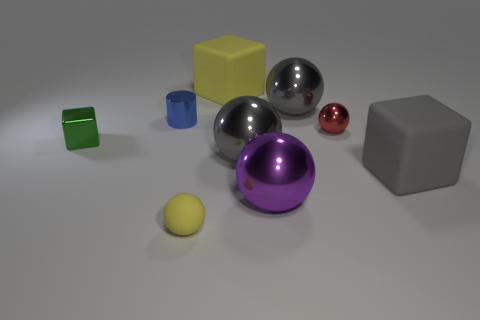Is there anything else that has the same shape as the tiny blue metal object?
Keep it short and to the point. No. Is there a gray thing of the same size as the purple metallic ball?
Give a very brief answer. Yes. Is the color of the matte cube that is in front of the small green shiny object the same as the metallic block?
Give a very brief answer. No. There is a rubber object that is left of the purple metallic object and in front of the tiny shiny block; what color is it?
Make the answer very short. Yellow. There is a blue metal object that is the same size as the yellow ball; what shape is it?
Give a very brief answer. Cylinder. Is there another tiny blue thing of the same shape as the blue metallic object?
Provide a short and direct response. No. There is a ball behind the cylinder; is it the same size as the large gray block?
Your response must be concise. Yes. There is a metallic object that is in front of the small blue object and left of the yellow cube; how big is it?
Offer a terse response. Small. What number of other things are the same material as the blue object?
Your response must be concise. 5. What size is the yellow rubber thing behind the tiny rubber ball?
Your response must be concise. Large. 